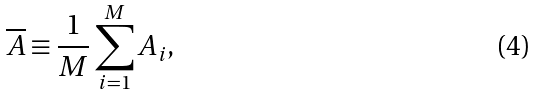<formula> <loc_0><loc_0><loc_500><loc_500>\overline { A } \equiv \frac { 1 } { M } \sum _ { i = 1 } ^ { M } A _ { i } ,</formula> 